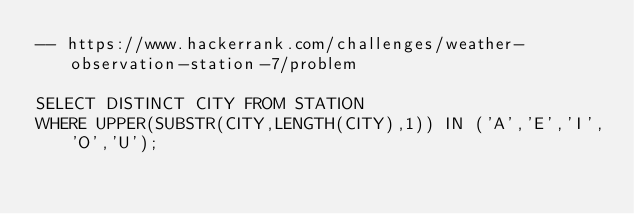Convert code to text. <code><loc_0><loc_0><loc_500><loc_500><_SQL_>-- https://www.hackerrank.com/challenges/weather-observation-station-7/problem

SELECT DISTINCT CITY FROM STATION 
WHERE UPPER(SUBSTR(CITY,LENGTH(CITY),1)) IN ('A','E','I','O','U');</code> 